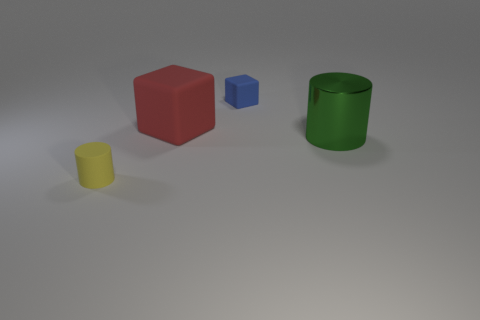Add 2 tiny yellow spheres. How many objects exist? 6 Add 1 brown cylinders. How many brown cylinders exist? 1 Subtract 0 brown cylinders. How many objects are left? 4 Subtract all large cylinders. Subtract all small blue blocks. How many objects are left? 2 Add 4 blue blocks. How many blue blocks are left? 5 